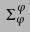Convert formula to latex. <formula><loc_0><loc_0><loc_500><loc_500>\Sigma _ { \varphi } ^ { \varphi }</formula> 